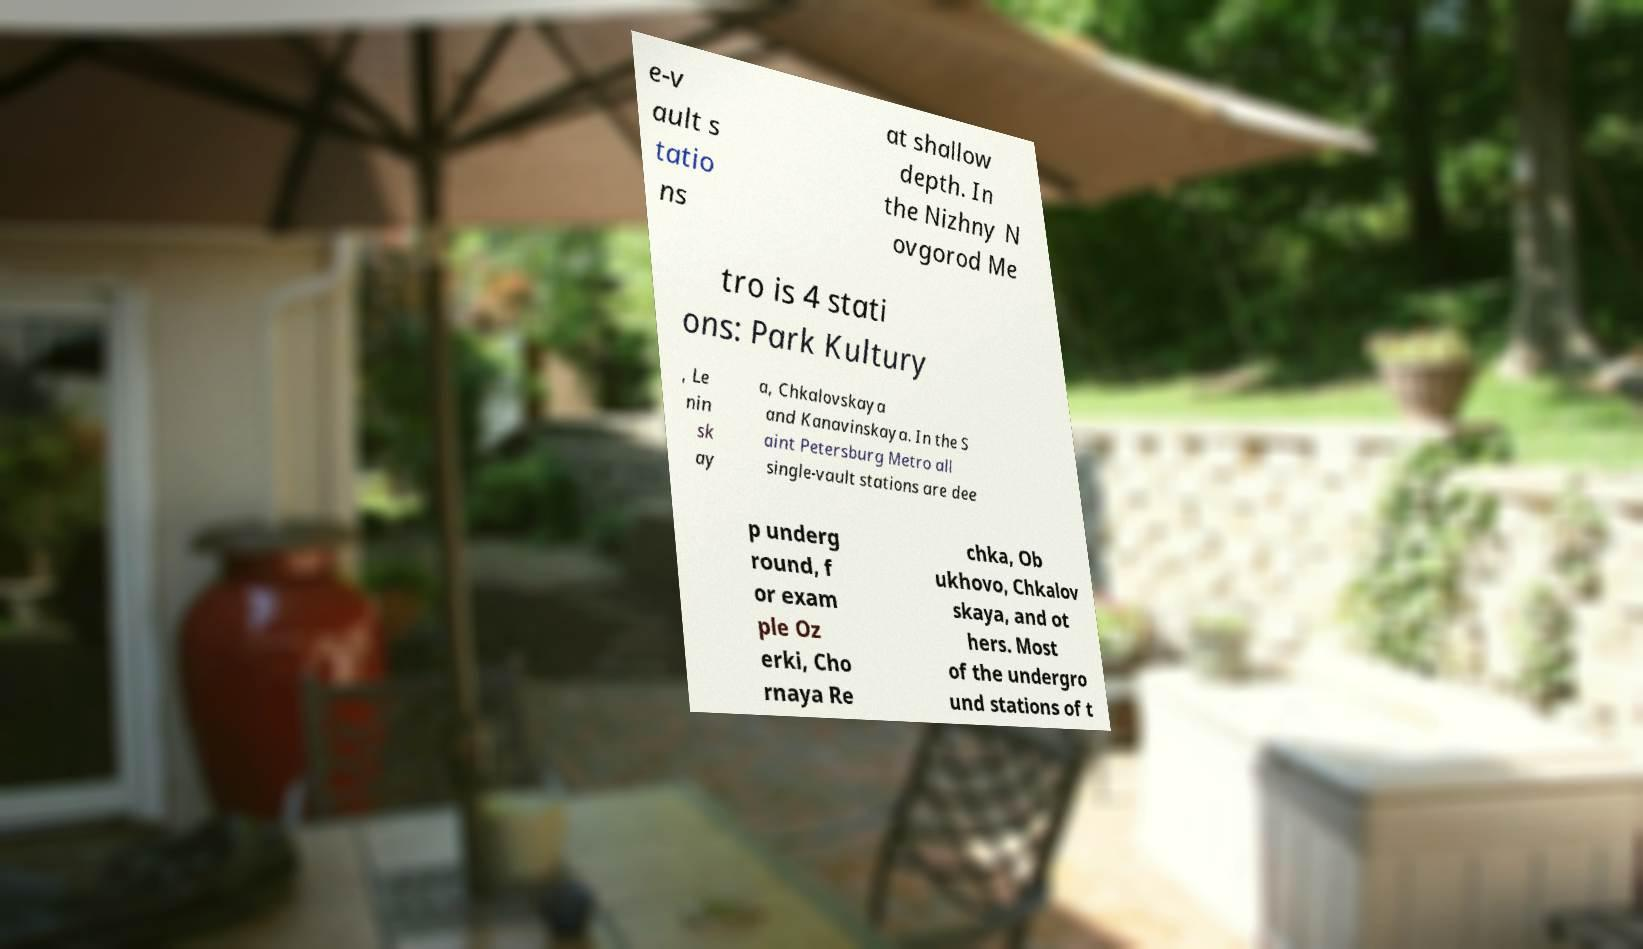Please identify and transcribe the text found in this image. e-v ault s tatio ns at shallow depth. In the Nizhny N ovgorod Me tro is 4 stati ons: Park Kultury , Le nin sk ay a, Chkalovskaya and Kanavinskaya. In the S aint Petersburg Metro all single-vault stations are dee p underg round, f or exam ple Oz erki, Cho rnaya Re chka, Ob ukhovo, Chkalov skaya, and ot hers. Most of the undergro und stations of t 